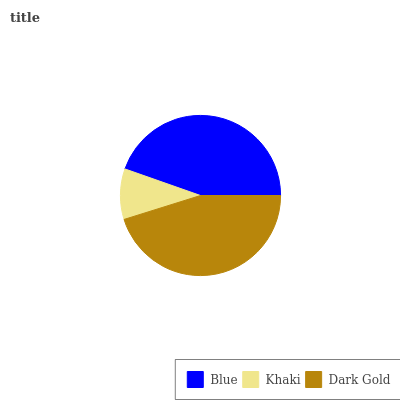Is Khaki the minimum?
Answer yes or no. Yes. Is Dark Gold the maximum?
Answer yes or no. Yes. Is Dark Gold the minimum?
Answer yes or no. No. Is Khaki the maximum?
Answer yes or no. No. Is Dark Gold greater than Khaki?
Answer yes or no. Yes. Is Khaki less than Dark Gold?
Answer yes or no. Yes. Is Khaki greater than Dark Gold?
Answer yes or no. No. Is Dark Gold less than Khaki?
Answer yes or no. No. Is Blue the high median?
Answer yes or no. Yes. Is Blue the low median?
Answer yes or no. Yes. Is Khaki the high median?
Answer yes or no. No. Is Khaki the low median?
Answer yes or no. No. 